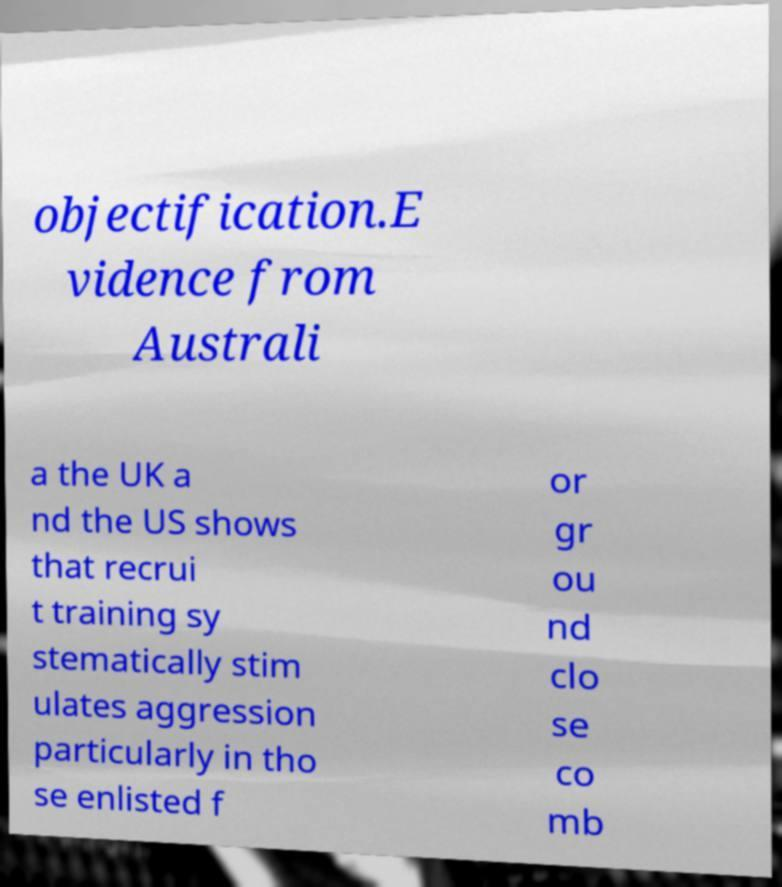Could you extract and type out the text from this image? objectification.E vidence from Australi a the UK a nd the US shows that recrui t training sy stematically stim ulates aggression particularly in tho se enlisted f or gr ou nd clo se co mb 